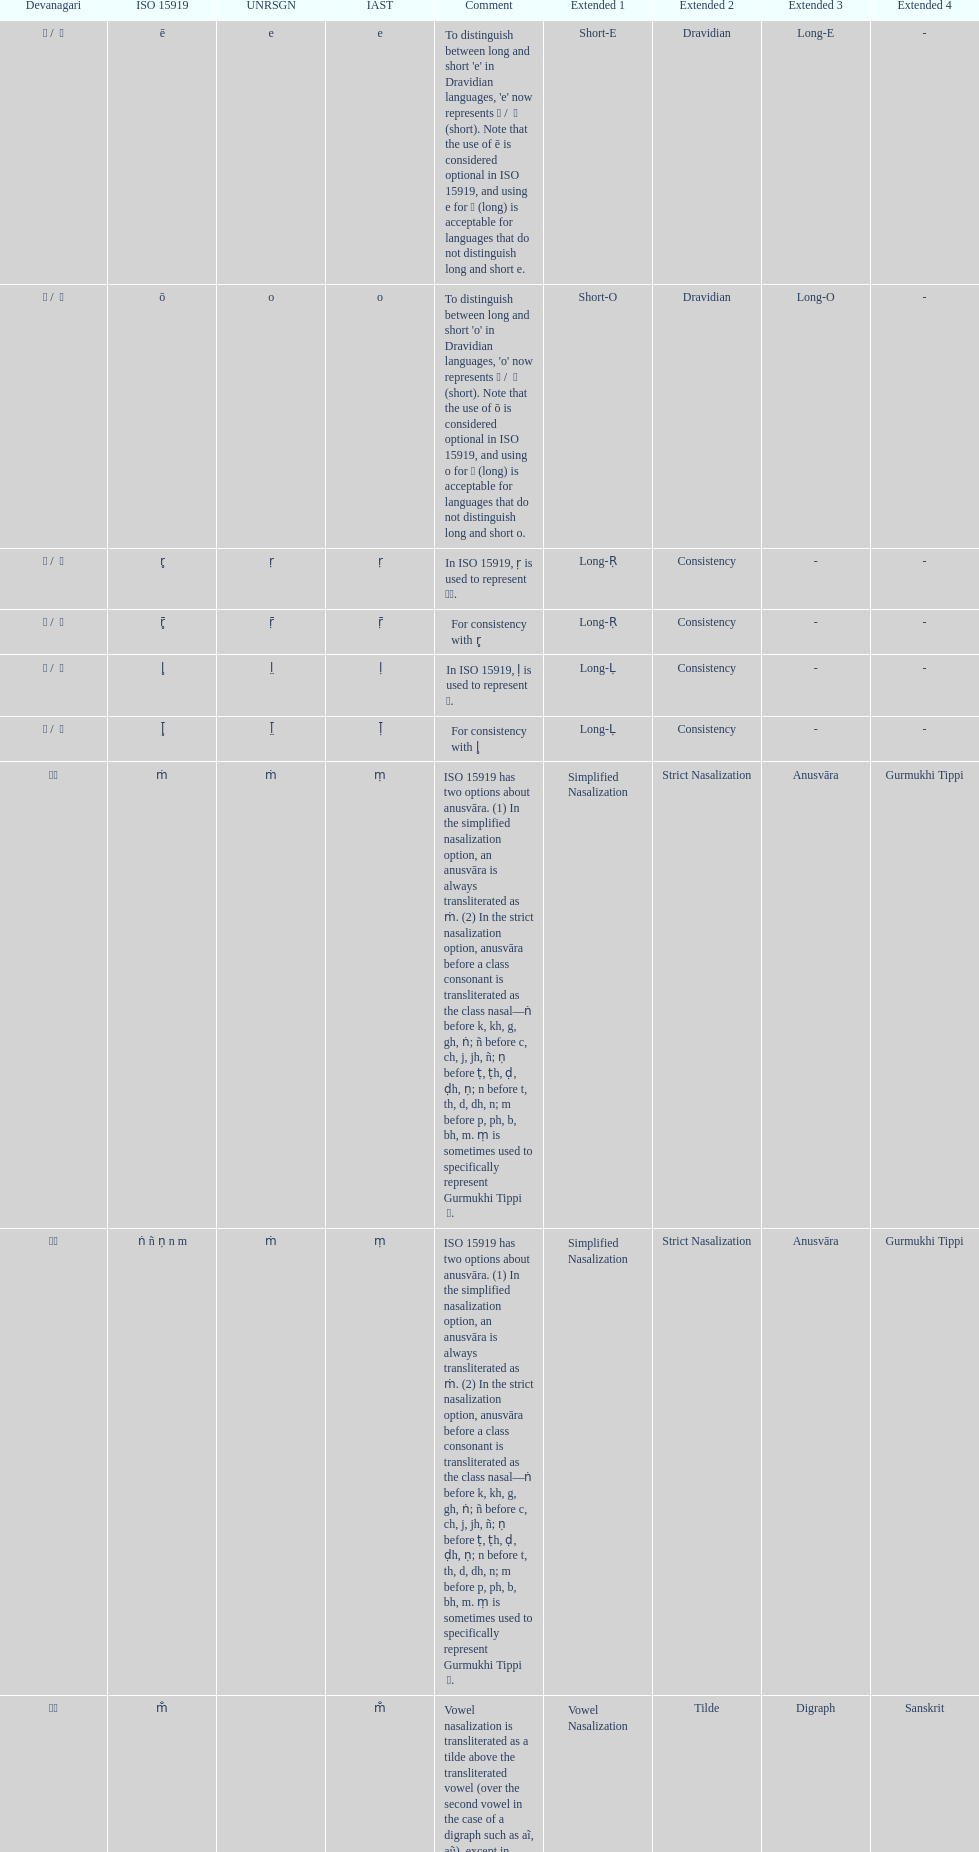This table shows the difference between how many transliterations? 3. 